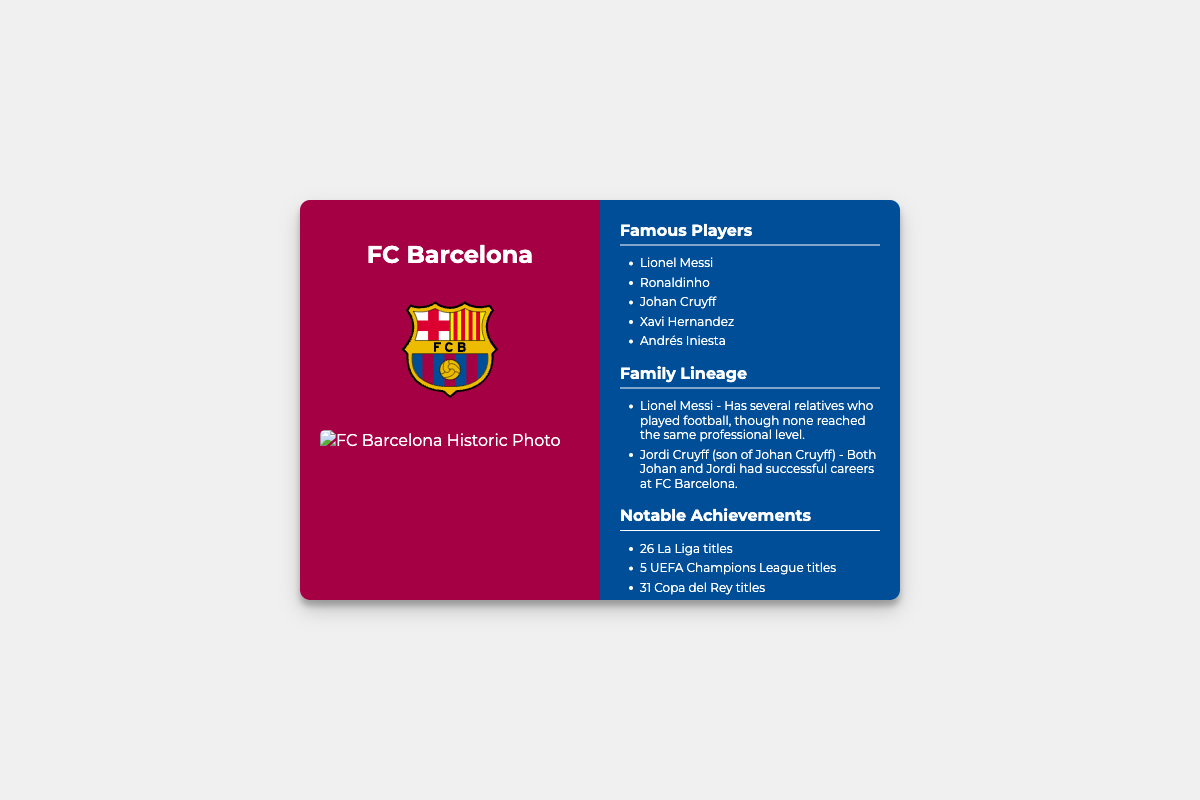What is the name of the club? The name of the club is listed prominently on the front of the card.
Answer: FC Barcelona How many La Liga titles has the club won? The document lists the notable achievements of the club, which includes the number of La Liga titles won.
Answer: 26 Who is the son of Johan Cruyff mentioned in the document? The document lists players and lineage connections, specifically mentioning Johan Cruyff's son.
Answer: Jordi Cruyff What is the color of the back of the card? The back of the card has a specific color mentioned in the styling section of the document.
Answer: Dark blue How many UEFA Champions League titles has FC Barcelona won? The notable achievements section states the total number of UEFA Champions League titles the club has.
Answer: 5 Which player is noted for having several relatives who played football? The document highlights a specific player with family connections in football.
Answer: Lionel Messi What type of document is this? The layout and sections indicate that this is a business card designed to showcase club history.
Answer: Business card What is the scroll hint text at the bottom of the back? The back includes a cue for further exploration or reading and is clearly stated.
Answer: Scroll for more info 